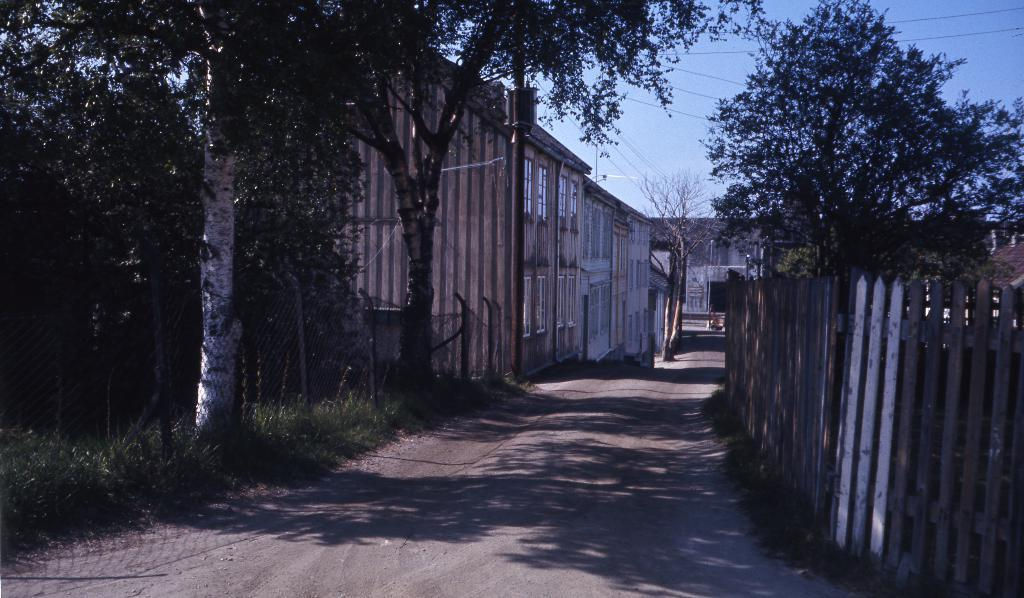What type of vegetation can be seen in the image? There are trees in the image. What is located on the right side of the image? There is fencing on the right side of the image. What can be seen in the background of the image? There are houses in the background of the image. What is visible at the top of the image? The sky is visible at the top of the image. What is the condition of the sky in the image? Clouds are present in the sky. How many sheep are grazing in the field in the image? There are no sheep present in the image; it features trees, fencing, houses, and a sky with clouds. What type of gold object is visible in the image? There is no gold object present in the image. 